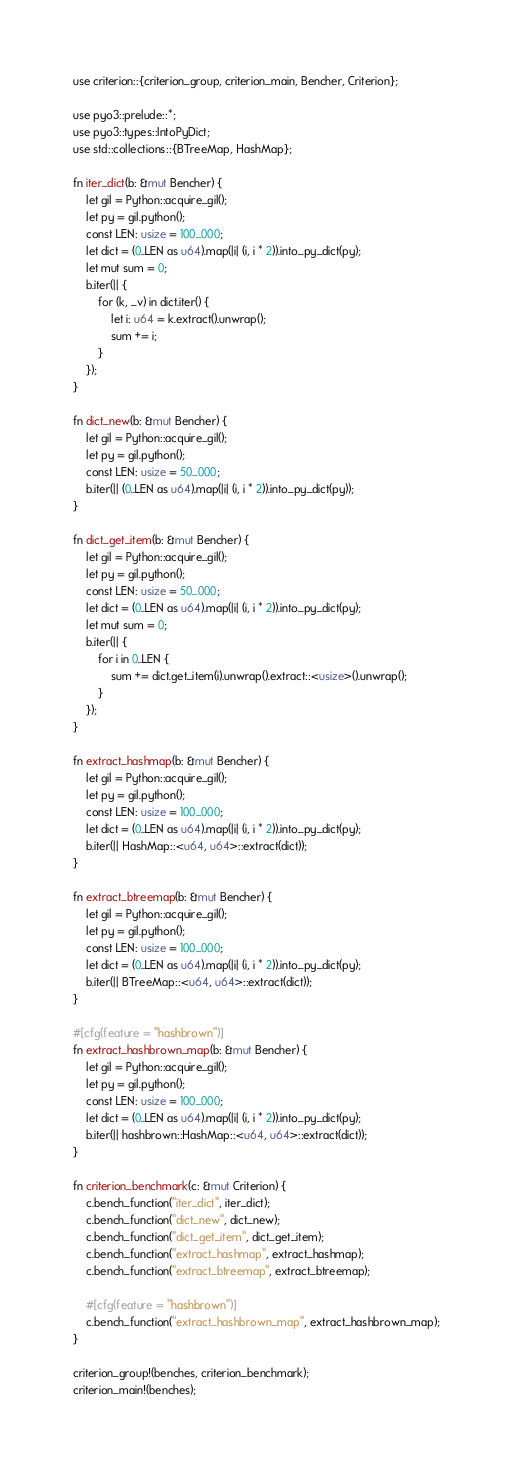Convert code to text. <code><loc_0><loc_0><loc_500><loc_500><_Rust_>use criterion::{criterion_group, criterion_main, Bencher, Criterion};

use pyo3::prelude::*;
use pyo3::types::IntoPyDict;
use std::collections::{BTreeMap, HashMap};

fn iter_dict(b: &mut Bencher) {
    let gil = Python::acquire_gil();
    let py = gil.python();
    const LEN: usize = 100_000;
    let dict = (0..LEN as u64).map(|i| (i, i * 2)).into_py_dict(py);
    let mut sum = 0;
    b.iter(|| {
        for (k, _v) in dict.iter() {
            let i: u64 = k.extract().unwrap();
            sum += i;
        }
    });
}

fn dict_new(b: &mut Bencher) {
    let gil = Python::acquire_gil();
    let py = gil.python();
    const LEN: usize = 50_000;
    b.iter(|| (0..LEN as u64).map(|i| (i, i * 2)).into_py_dict(py));
}

fn dict_get_item(b: &mut Bencher) {
    let gil = Python::acquire_gil();
    let py = gil.python();
    const LEN: usize = 50_000;
    let dict = (0..LEN as u64).map(|i| (i, i * 2)).into_py_dict(py);
    let mut sum = 0;
    b.iter(|| {
        for i in 0..LEN {
            sum += dict.get_item(i).unwrap().extract::<usize>().unwrap();
        }
    });
}

fn extract_hashmap(b: &mut Bencher) {
    let gil = Python::acquire_gil();
    let py = gil.python();
    const LEN: usize = 100_000;
    let dict = (0..LEN as u64).map(|i| (i, i * 2)).into_py_dict(py);
    b.iter(|| HashMap::<u64, u64>::extract(dict));
}

fn extract_btreemap(b: &mut Bencher) {
    let gil = Python::acquire_gil();
    let py = gil.python();
    const LEN: usize = 100_000;
    let dict = (0..LEN as u64).map(|i| (i, i * 2)).into_py_dict(py);
    b.iter(|| BTreeMap::<u64, u64>::extract(dict));
}

#[cfg(feature = "hashbrown")]
fn extract_hashbrown_map(b: &mut Bencher) {
    let gil = Python::acquire_gil();
    let py = gil.python();
    const LEN: usize = 100_000;
    let dict = (0..LEN as u64).map(|i| (i, i * 2)).into_py_dict(py);
    b.iter(|| hashbrown::HashMap::<u64, u64>::extract(dict));
}

fn criterion_benchmark(c: &mut Criterion) {
    c.bench_function("iter_dict", iter_dict);
    c.bench_function("dict_new", dict_new);
    c.bench_function("dict_get_item", dict_get_item);
    c.bench_function("extract_hashmap", extract_hashmap);
    c.bench_function("extract_btreemap", extract_btreemap);

    #[cfg(feature = "hashbrown")]
    c.bench_function("extract_hashbrown_map", extract_hashbrown_map);
}

criterion_group!(benches, criterion_benchmark);
criterion_main!(benches);
</code> 